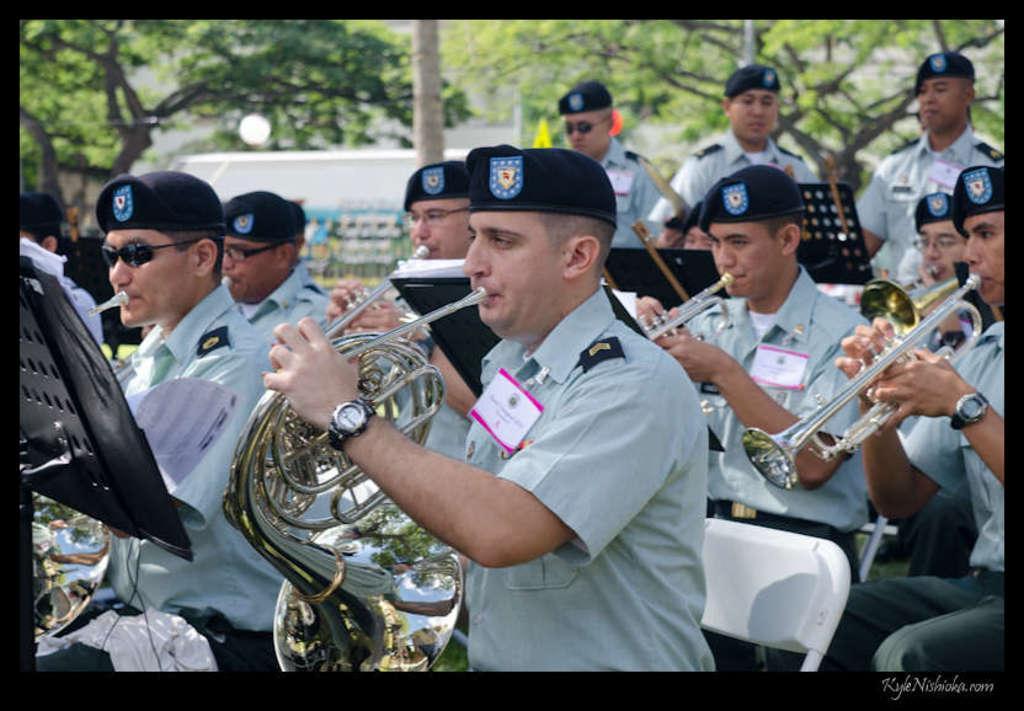Describe this image in one or two sentences. Here in this picture we can see a group of people sitting on chairs over there and we can see all of them are wearing same kind of clothes on them and wearing caps on them and all of them are playing musical instruments present in their hands and behind them also we can see some people standing and we can see trees present all over there. 